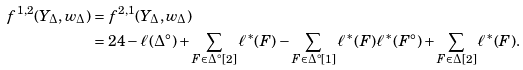Convert formula to latex. <formula><loc_0><loc_0><loc_500><loc_500>f ^ { 1 , 2 } ( Y _ { \Delta } , w _ { \Delta } ) & = f ^ { 2 , 1 } ( Y _ { \Delta } , w _ { \Delta } ) \\ & = 2 4 - \ell ( \Delta ^ { \circ } ) + \sum _ { F \in \Delta ^ { \circ } [ 2 ] } \ell ^ { * } ( F ) - \sum _ { F \in \Delta ^ { \circ } [ 1 ] } \ell ^ { * } ( F ) \ell ^ { * } ( F ^ { \circ } ) + \sum _ { F \in \Delta [ 2 ] } \ell ^ { * } ( F ) .</formula> 